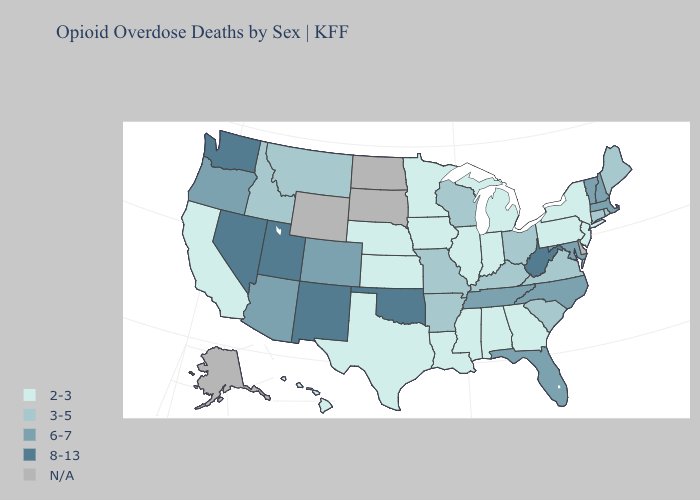Which states have the highest value in the USA?
Give a very brief answer. Nevada, New Mexico, Oklahoma, Utah, Washington, West Virginia. Name the states that have a value in the range 3-5?
Quick response, please. Arkansas, Connecticut, Idaho, Kentucky, Maine, Missouri, Montana, Ohio, Rhode Island, South Carolina, Virginia, Wisconsin. Does Utah have the lowest value in the USA?
Quick response, please. No. What is the value of Connecticut?
Give a very brief answer. 3-5. Name the states that have a value in the range 2-3?
Write a very short answer. Alabama, California, Georgia, Hawaii, Illinois, Indiana, Iowa, Kansas, Louisiana, Michigan, Minnesota, Mississippi, Nebraska, New Jersey, New York, Pennsylvania, Texas. Does Utah have the lowest value in the West?
Write a very short answer. No. Among the states that border Illinois , which have the lowest value?
Short answer required. Indiana, Iowa. What is the value of Oregon?
Keep it brief. 6-7. Does Nevada have the highest value in the USA?
Concise answer only. Yes. What is the value of North Carolina?
Concise answer only. 6-7. Name the states that have a value in the range 6-7?
Write a very short answer. Arizona, Colorado, Florida, Maryland, Massachusetts, New Hampshire, North Carolina, Oregon, Tennessee, Vermont. Name the states that have a value in the range 2-3?
Give a very brief answer. Alabama, California, Georgia, Hawaii, Illinois, Indiana, Iowa, Kansas, Louisiana, Michigan, Minnesota, Mississippi, Nebraska, New Jersey, New York, Pennsylvania, Texas. What is the value of Alabama?
Be succinct. 2-3. 